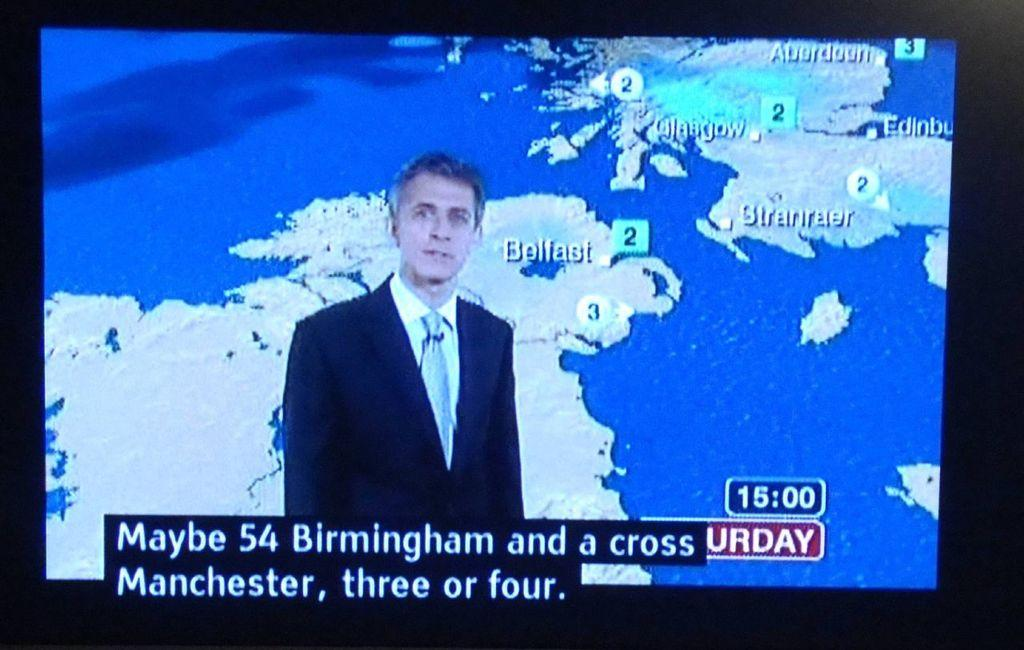Provide a one-sentence caption for the provided image. The man reporting the Saturday weather is dressed in a dark suit jacket with a tie. 